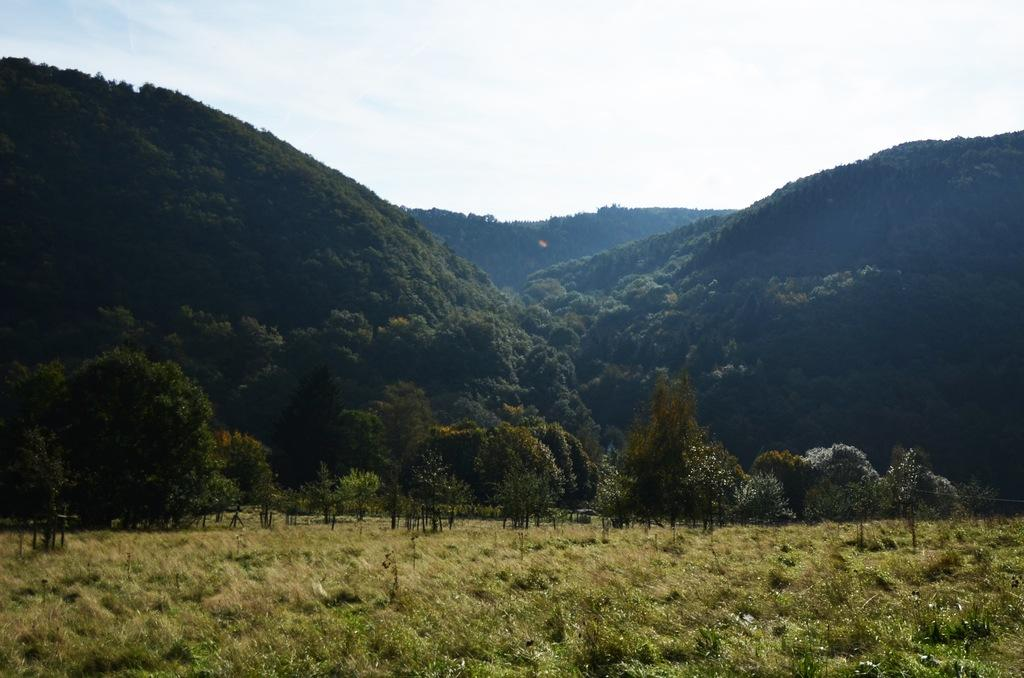What type of vegetation can be seen in the image? There are plants and trees in the image. What type of natural landform is visible in the image? There are mountains in the image. What part of the natural environment is visible in the image? The sky is visible in the image. What type of organization is depicted in the image? There is no organization present in the image; it features plants, trees, mountains, and the sky. Can you tell me what toy is being used by the plants in the image? There are no toys present in the image; it features plants, trees, mountains, and the sky. 